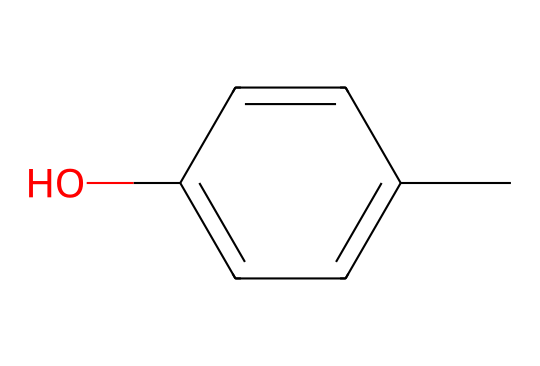What is the main functional group in p-cresol? In the SMILES representation, the "O" indicates the presence of a hydroxyl group (-OH), which is the key functional group in phenols.
Answer: hydroxyl group How many carbon atoms are in p-cresol? By breaking down the SMILES structure, "Cc1ccc(O)cc1", we identify six carbon atoms in total: one from the methyl group (C) and five from the aromatic ring (c1ccc(cc)).
Answer: six What type of compound is p-cresol classified as? The presence of the hydroxyl group on an aromatic ring classifies this compound as a phenol, which is recognized for its characteristic properties and chemical behavior.
Answer: phenol How many hydrogen atoms are in p-cresol? Analyzing the structure, we see that the aromatic ring's carbon atoms are each bonded to one hydrogen, plus one hydrogen from the methyl group, resulting in a total of eight hydrogen atoms when accounting for the hydroxyl group's hydrogen as well.
Answer: eight What is the molecular formula of p-cresol? Counting the atoms from the full structure leads us to the formula C7H8O, comprised of six carbons, eight hydrogens, and one oxygen, which is typical of phenolic compounds.
Answer: C7H8O Is p-cresol soluble in water? The presence of the hydroxyl group contributes to the solubility of p-cresol in water due to hydrogen bonding capabilities, common for phenolic compounds.
Answer: yes 